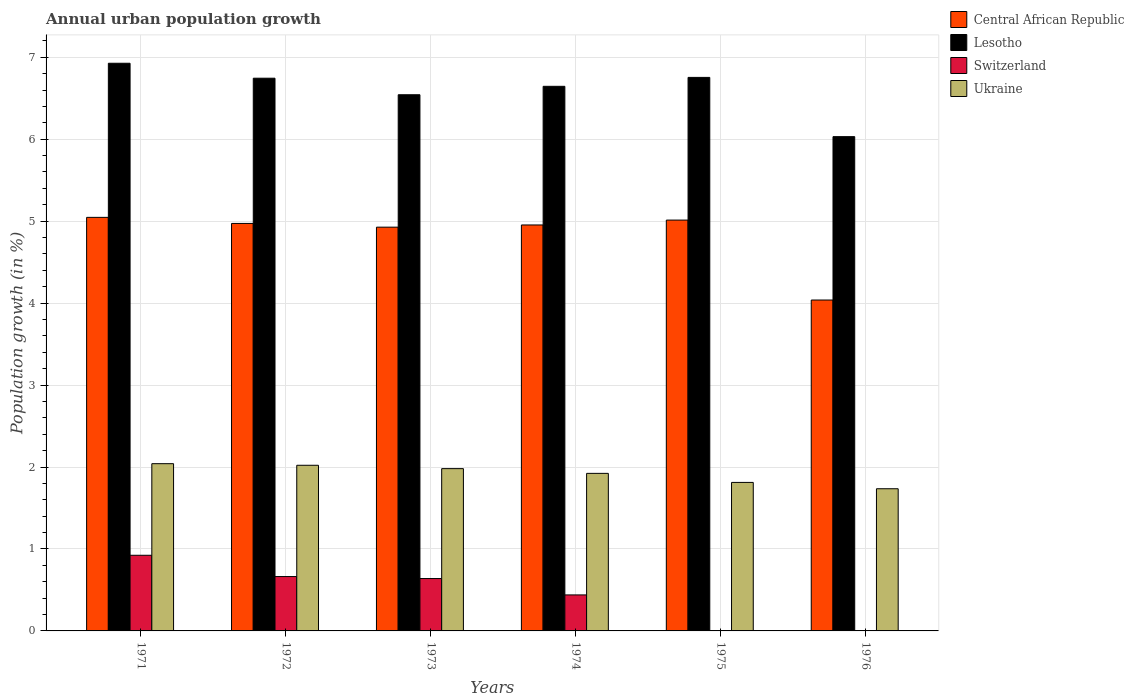How many different coloured bars are there?
Give a very brief answer. 4. Are the number of bars on each tick of the X-axis equal?
Your answer should be very brief. No. How many bars are there on the 5th tick from the right?
Your answer should be compact. 4. What is the label of the 2nd group of bars from the left?
Provide a short and direct response. 1972. In how many cases, is the number of bars for a given year not equal to the number of legend labels?
Keep it short and to the point. 2. What is the percentage of urban population growth in Ukraine in 1972?
Your response must be concise. 2.02. Across all years, what is the maximum percentage of urban population growth in Ukraine?
Make the answer very short. 2.04. What is the total percentage of urban population growth in Central African Republic in the graph?
Provide a short and direct response. 28.95. What is the difference between the percentage of urban population growth in Lesotho in 1972 and that in 1973?
Make the answer very short. 0.2. What is the difference between the percentage of urban population growth in Ukraine in 1975 and the percentage of urban population growth in Central African Republic in 1976?
Keep it short and to the point. -2.23. What is the average percentage of urban population growth in Ukraine per year?
Your answer should be very brief. 1.92. In the year 1975, what is the difference between the percentage of urban population growth in Central African Republic and percentage of urban population growth in Lesotho?
Your answer should be very brief. -1.74. What is the ratio of the percentage of urban population growth in Ukraine in 1973 to that in 1975?
Offer a terse response. 1.09. What is the difference between the highest and the second highest percentage of urban population growth in Central African Republic?
Make the answer very short. 0.03. What is the difference between the highest and the lowest percentage of urban population growth in Central African Republic?
Give a very brief answer. 1.01. Is the sum of the percentage of urban population growth in Lesotho in 1972 and 1975 greater than the maximum percentage of urban population growth in Switzerland across all years?
Ensure brevity in your answer.  Yes. What is the difference between two consecutive major ticks on the Y-axis?
Provide a short and direct response. 1. Are the values on the major ticks of Y-axis written in scientific E-notation?
Ensure brevity in your answer.  No. Does the graph contain grids?
Your response must be concise. Yes. Where does the legend appear in the graph?
Your response must be concise. Top right. What is the title of the graph?
Your answer should be very brief. Annual urban population growth. Does "South Africa" appear as one of the legend labels in the graph?
Offer a very short reply. No. What is the label or title of the Y-axis?
Your answer should be very brief. Population growth (in %). What is the Population growth (in %) of Central African Republic in 1971?
Your answer should be very brief. 5.05. What is the Population growth (in %) in Lesotho in 1971?
Give a very brief answer. 6.93. What is the Population growth (in %) in Switzerland in 1971?
Ensure brevity in your answer.  0.92. What is the Population growth (in %) in Ukraine in 1971?
Offer a very short reply. 2.04. What is the Population growth (in %) in Central African Republic in 1972?
Keep it short and to the point. 4.97. What is the Population growth (in %) in Lesotho in 1972?
Your response must be concise. 6.74. What is the Population growth (in %) of Switzerland in 1972?
Ensure brevity in your answer.  0.66. What is the Population growth (in %) in Ukraine in 1972?
Your answer should be very brief. 2.02. What is the Population growth (in %) of Central African Republic in 1973?
Ensure brevity in your answer.  4.93. What is the Population growth (in %) of Lesotho in 1973?
Provide a succinct answer. 6.54. What is the Population growth (in %) in Switzerland in 1973?
Ensure brevity in your answer.  0.64. What is the Population growth (in %) of Ukraine in 1973?
Give a very brief answer. 1.98. What is the Population growth (in %) of Central African Republic in 1974?
Keep it short and to the point. 4.95. What is the Population growth (in %) of Lesotho in 1974?
Give a very brief answer. 6.65. What is the Population growth (in %) in Switzerland in 1974?
Keep it short and to the point. 0.44. What is the Population growth (in %) of Ukraine in 1974?
Offer a terse response. 1.92. What is the Population growth (in %) of Central African Republic in 1975?
Your answer should be compact. 5.01. What is the Population growth (in %) of Lesotho in 1975?
Give a very brief answer. 6.75. What is the Population growth (in %) in Ukraine in 1975?
Give a very brief answer. 1.81. What is the Population growth (in %) in Central African Republic in 1976?
Keep it short and to the point. 4.04. What is the Population growth (in %) in Lesotho in 1976?
Your answer should be very brief. 6.03. What is the Population growth (in %) of Ukraine in 1976?
Your answer should be very brief. 1.73. Across all years, what is the maximum Population growth (in %) in Central African Republic?
Make the answer very short. 5.05. Across all years, what is the maximum Population growth (in %) in Lesotho?
Give a very brief answer. 6.93. Across all years, what is the maximum Population growth (in %) of Switzerland?
Offer a very short reply. 0.92. Across all years, what is the maximum Population growth (in %) in Ukraine?
Offer a terse response. 2.04. Across all years, what is the minimum Population growth (in %) of Central African Republic?
Make the answer very short. 4.04. Across all years, what is the minimum Population growth (in %) in Lesotho?
Provide a succinct answer. 6.03. Across all years, what is the minimum Population growth (in %) of Ukraine?
Your answer should be very brief. 1.73. What is the total Population growth (in %) of Central African Republic in the graph?
Give a very brief answer. 28.95. What is the total Population growth (in %) in Lesotho in the graph?
Give a very brief answer. 39.64. What is the total Population growth (in %) of Switzerland in the graph?
Give a very brief answer. 2.67. What is the total Population growth (in %) of Ukraine in the graph?
Your answer should be compact. 11.51. What is the difference between the Population growth (in %) in Central African Republic in 1971 and that in 1972?
Provide a succinct answer. 0.07. What is the difference between the Population growth (in %) of Lesotho in 1971 and that in 1972?
Provide a succinct answer. 0.18. What is the difference between the Population growth (in %) of Switzerland in 1971 and that in 1972?
Offer a terse response. 0.26. What is the difference between the Population growth (in %) of Ukraine in 1971 and that in 1972?
Your answer should be very brief. 0.02. What is the difference between the Population growth (in %) in Central African Republic in 1971 and that in 1973?
Your response must be concise. 0.12. What is the difference between the Population growth (in %) of Lesotho in 1971 and that in 1973?
Your answer should be very brief. 0.38. What is the difference between the Population growth (in %) in Switzerland in 1971 and that in 1973?
Give a very brief answer. 0.28. What is the difference between the Population growth (in %) in Ukraine in 1971 and that in 1973?
Make the answer very short. 0.06. What is the difference between the Population growth (in %) of Central African Republic in 1971 and that in 1974?
Your response must be concise. 0.09. What is the difference between the Population growth (in %) in Lesotho in 1971 and that in 1974?
Your response must be concise. 0.28. What is the difference between the Population growth (in %) in Switzerland in 1971 and that in 1974?
Ensure brevity in your answer.  0.48. What is the difference between the Population growth (in %) in Ukraine in 1971 and that in 1974?
Offer a terse response. 0.12. What is the difference between the Population growth (in %) of Central African Republic in 1971 and that in 1975?
Your answer should be compact. 0.03. What is the difference between the Population growth (in %) of Lesotho in 1971 and that in 1975?
Your answer should be very brief. 0.17. What is the difference between the Population growth (in %) in Ukraine in 1971 and that in 1975?
Your answer should be very brief. 0.23. What is the difference between the Population growth (in %) of Central African Republic in 1971 and that in 1976?
Provide a short and direct response. 1.01. What is the difference between the Population growth (in %) in Lesotho in 1971 and that in 1976?
Offer a terse response. 0.9. What is the difference between the Population growth (in %) of Ukraine in 1971 and that in 1976?
Your answer should be compact. 0.31. What is the difference between the Population growth (in %) of Central African Republic in 1972 and that in 1973?
Offer a very short reply. 0.05. What is the difference between the Population growth (in %) in Lesotho in 1972 and that in 1973?
Your answer should be very brief. 0.2. What is the difference between the Population growth (in %) in Switzerland in 1972 and that in 1973?
Offer a very short reply. 0.02. What is the difference between the Population growth (in %) in Ukraine in 1972 and that in 1973?
Provide a succinct answer. 0.04. What is the difference between the Population growth (in %) in Central African Republic in 1972 and that in 1974?
Offer a terse response. 0.02. What is the difference between the Population growth (in %) in Lesotho in 1972 and that in 1974?
Offer a terse response. 0.1. What is the difference between the Population growth (in %) in Switzerland in 1972 and that in 1974?
Your answer should be very brief. 0.22. What is the difference between the Population growth (in %) of Ukraine in 1972 and that in 1974?
Give a very brief answer. 0.1. What is the difference between the Population growth (in %) of Central African Republic in 1972 and that in 1975?
Make the answer very short. -0.04. What is the difference between the Population growth (in %) in Lesotho in 1972 and that in 1975?
Your answer should be very brief. -0.01. What is the difference between the Population growth (in %) of Ukraine in 1972 and that in 1975?
Your response must be concise. 0.21. What is the difference between the Population growth (in %) in Central African Republic in 1972 and that in 1976?
Provide a short and direct response. 0.93. What is the difference between the Population growth (in %) of Lesotho in 1972 and that in 1976?
Ensure brevity in your answer.  0.71. What is the difference between the Population growth (in %) of Ukraine in 1972 and that in 1976?
Your answer should be compact. 0.29. What is the difference between the Population growth (in %) in Central African Republic in 1973 and that in 1974?
Provide a short and direct response. -0.03. What is the difference between the Population growth (in %) in Lesotho in 1973 and that in 1974?
Make the answer very short. -0.1. What is the difference between the Population growth (in %) of Switzerland in 1973 and that in 1974?
Ensure brevity in your answer.  0.2. What is the difference between the Population growth (in %) of Ukraine in 1973 and that in 1974?
Offer a terse response. 0.06. What is the difference between the Population growth (in %) in Central African Republic in 1973 and that in 1975?
Give a very brief answer. -0.09. What is the difference between the Population growth (in %) in Lesotho in 1973 and that in 1975?
Provide a short and direct response. -0.21. What is the difference between the Population growth (in %) of Ukraine in 1973 and that in 1975?
Keep it short and to the point. 0.17. What is the difference between the Population growth (in %) of Central African Republic in 1973 and that in 1976?
Make the answer very short. 0.89. What is the difference between the Population growth (in %) in Lesotho in 1973 and that in 1976?
Make the answer very short. 0.51. What is the difference between the Population growth (in %) of Ukraine in 1973 and that in 1976?
Keep it short and to the point. 0.25. What is the difference between the Population growth (in %) in Central African Republic in 1974 and that in 1975?
Offer a very short reply. -0.06. What is the difference between the Population growth (in %) in Lesotho in 1974 and that in 1975?
Provide a succinct answer. -0.11. What is the difference between the Population growth (in %) of Ukraine in 1974 and that in 1975?
Offer a terse response. 0.11. What is the difference between the Population growth (in %) of Central African Republic in 1974 and that in 1976?
Keep it short and to the point. 0.92. What is the difference between the Population growth (in %) in Lesotho in 1974 and that in 1976?
Your response must be concise. 0.61. What is the difference between the Population growth (in %) of Ukraine in 1974 and that in 1976?
Ensure brevity in your answer.  0.19. What is the difference between the Population growth (in %) in Central African Republic in 1975 and that in 1976?
Provide a succinct answer. 0.98. What is the difference between the Population growth (in %) of Lesotho in 1975 and that in 1976?
Give a very brief answer. 0.72. What is the difference between the Population growth (in %) in Ukraine in 1975 and that in 1976?
Provide a succinct answer. 0.08. What is the difference between the Population growth (in %) in Central African Republic in 1971 and the Population growth (in %) in Lesotho in 1972?
Your response must be concise. -1.7. What is the difference between the Population growth (in %) of Central African Republic in 1971 and the Population growth (in %) of Switzerland in 1972?
Ensure brevity in your answer.  4.38. What is the difference between the Population growth (in %) in Central African Republic in 1971 and the Population growth (in %) in Ukraine in 1972?
Ensure brevity in your answer.  3.02. What is the difference between the Population growth (in %) of Lesotho in 1971 and the Population growth (in %) of Switzerland in 1972?
Offer a terse response. 6.26. What is the difference between the Population growth (in %) of Lesotho in 1971 and the Population growth (in %) of Ukraine in 1972?
Keep it short and to the point. 4.91. What is the difference between the Population growth (in %) of Switzerland in 1971 and the Population growth (in %) of Ukraine in 1972?
Provide a succinct answer. -1.1. What is the difference between the Population growth (in %) in Central African Republic in 1971 and the Population growth (in %) in Lesotho in 1973?
Keep it short and to the point. -1.5. What is the difference between the Population growth (in %) of Central African Republic in 1971 and the Population growth (in %) of Switzerland in 1973?
Ensure brevity in your answer.  4.41. What is the difference between the Population growth (in %) in Central African Republic in 1971 and the Population growth (in %) in Ukraine in 1973?
Keep it short and to the point. 3.07. What is the difference between the Population growth (in %) in Lesotho in 1971 and the Population growth (in %) in Switzerland in 1973?
Offer a terse response. 6.29. What is the difference between the Population growth (in %) in Lesotho in 1971 and the Population growth (in %) in Ukraine in 1973?
Your response must be concise. 4.95. What is the difference between the Population growth (in %) of Switzerland in 1971 and the Population growth (in %) of Ukraine in 1973?
Give a very brief answer. -1.06. What is the difference between the Population growth (in %) of Central African Republic in 1971 and the Population growth (in %) of Lesotho in 1974?
Provide a succinct answer. -1.6. What is the difference between the Population growth (in %) in Central African Republic in 1971 and the Population growth (in %) in Switzerland in 1974?
Provide a short and direct response. 4.61. What is the difference between the Population growth (in %) of Central African Republic in 1971 and the Population growth (in %) of Ukraine in 1974?
Make the answer very short. 3.12. What is the difference between the Population growth (in %) in Lesotho in 1971 and the Population growth (in %) in Switzerland in 1974?
Keep it short and to the point. 6.49. What is the difference between the Population growth (in %) of Lesotho in 1971 and the Population growth (in %) of Ukraine in 1974?
Your answer should be very brief. 5. What is the difference between the Population growth (in %) in Switzerland in 1971 and the Population growth (in %) in Ukraine in 1974?
Your response must be concise. -1. What is the difference between the Population growth (in %) in Central African Republic in 1971 and the Population growth (in %) in Lesotho in 1975?
Your answer should be compact. -1.71. What is the difference between the Population growth (in %) in Central African Republic in 1971 and the Population growth (in %) in Ukraine in 1975?
Provide a short and direct response. 3.23. What is the difference between the Population growth (in %) of Lesotho in 1971 and the Population growth (in %) of Ukraine in 1975?
Ensure brevity in your answer.  5.11. What is the difference between the Population growth (in %) of Switzerland in 1971 and the Population growth (in %) of Ukraine in 1975?
Make the answer very short. -0.89. What is the difference between the Population growth (in %) of Central African Republic in 1971 and the Population growth (in %) of Lesotho in 1976?
Provide a short and direct response. -0.98. What is the difference between the Population growth (in %) in Central African Republic in 1971 and the Population growth (in %) in Ukraine in 1976?
Give a very brief answer. 3.31. What is the difference between the Population growth (in %) of Lesotho in 1971 and the Population growth (in %) of Ukraine in 1976?
Ensure brevity in your answer.  5.19. What is the difference between the Population growth (in %) of Switzerland in 1971 and the Population growth (in %) of Ukraine in 1976?
Offer a very short reply. -0.81. What is the difference between the Population growth (in %) of Central African Republic in 1972 and the Population growth (in %) of Lesotho in 1973?
Provide a succinct answer. -1.57. What is the difference between the Population growth (in %) in Central African Republic in 1972 and the Population growth (in %) in Switzerland in 1973?
Your answer should be compact. 4.33. What is the difference between the Population growth (in %) in Central African Republic in 1972 and the Population growth (in %) in Ukraine in 1973?
Your response must be concise. 2.99. What is the difference between the Population growth (in %) in Lesotho in 1972 and the Population growth (in %) in Switzerland in 1973?
Make the answer very short. 6.11. What is the difference between the Population growth (in %) of Lesotho in 1972 and the Population growth (in %) of Ukraine in 1973?
Ensure brevity in your answer.  4.76. What is the difference between the Population growth (in %) of Switzerland in 1972 and the Population growth (in %) of Ukraine in 1973?
Offer a terse response. -1.32. What is the difference between the Population growth (in %) of Central African Republic in 1972 and the Population growth (in %) of Lesotho in 1974?
Your answer should be compact. -1.67. What is the difference between the Population growth (in %) of Central African Republic in 1972 and the Population growth (in %) of Switzerland in 1974?
Offer a terse response. 4.53. What is the difference between the Population growth (in %) of Central African Republic in 1972 and the Population growth (in %) of Ukraine in 1974?
Your answer should be very brief. 3.05. What is the difference between the Population growth (in %) in Lesotho in 1972 and the Population growth (in %) in Switzerland in 1974?
Provide a succinct answer. 6.3. What is the difference between the Population growth (in %) in Lesotho in 1972 and the Population growth (in %) in Ukraine in 1974?
Keep it short and to the point. 4.82. What is the difference between the Population growth (in %) in Switzerland in 1972 and the Population growth (in %) in Ukraine in 1974?
Ensure brevity in your answer.  -1.26. What is the difference between the Population growth (in %) of Central African Republic in 1972 and the Population growth (in %) of Lesotho in 1975?
Offer a very short reply. -1.78. What is the difference between the Population growth (in %) of Central African Republic in 1972 and the Population growth (in %) of Ukraine in 1975?
Make the answer very short. 3.16. What is the difference between the Population growth (in %) in Lesotho in 1972 and the Population growth (in %) in Ukraine in 1975?
Offer a very short reply. 4.93. What is the difference between the Population growth (in %) of Switzerland in 1972 and the Population growth (in %) of Ukraine in 1975?
Ensure brevity in your answer.  -1.15. What is the difference between the Population growth (in %) of Central African Republic in 1972 and the Population growth (in %) of Lesotho in 1976?
Make the answer very short. -1.06. What is the difference between the Population growth (in %) in Central African Republic in 1972 and the Population growth (in %) in Ukraine in 1976?
Offer a very short reply. 3.24. What is the difference between the Population growth (in %) in Lesotho in 1972 and the Population growth (in %) in Ukraine in 1976?
Offer a very short reply. 5.01. What is the difference between the Population growth (in %) in Switzerland in 1972 and the Population growth (in %) in Ukraine in 1976?
Provide a succinct answer. -1.07. What is the difference between the Population growth (in %) of Central African Republic in 1973 and the Population growth (in %) of Lesotho in 1974?
Your response must be concise. -1.72. What is the difference between the Population growth (in %) of Central African Republic in 1973 and the Population growth (in %) of Switzerland in 1974?
Provide a short and direct response. 4.49. What is the difference between the Population growth (in %) in Central African Republic in 1973 and the Population growth (in %) in Ukraine in 1974?
Offer a very short reply. 3. What is the difference between the Population growth (in %) in Lesotho in 1973 and the Population growth (in %) in Switzerland in 1974?
Ensure brevity in your answer.  6.1. What is the difference between the Population growth (in %) in Lesotho in 1973 and the Population growth (in %) in Ukraine in 1974?
Ensure brevity in your answer.  4.62. What is the difference between the Population growth (in %) of Switzerland in 1973 and the Population growth (in %) of Ukraine in 1974?
Give a very brief answer. -1.28. What is the difference between the Population growth (in %) of Central African Republic in 1973 and the Population growth (in %) of Lesotho in 1975?
Your answer should be very brief. -1.83. What is the difference between the Population growth (in %) of Central African Republic in 1973 and the Population growth (in %) of Ukraine in 1975?
Your answer should be compact. 3.11. What is the difference between the Population growth (in %) of Lesotho in 1973 and the Population growth (in %) of Ukraine in 1975?
Keep it short and to the point. 4.73. What is the difference between the Population growth (in %) of Switzerland in 1973 and the Population growth (in %) of Ukraine in 1975?
Provide a succinct answer. -1.17. What is the difference between the Population growth (in %) in Central African Republic in 1973 and the Population growth (in %) in Lesotho in 1976?
Provide a short and direct response. -1.1. What is the difference between the Population growth (in %) in Central African Republic in 1973 and the Population growth (in %) in Ukraine in 1976?
Keep it short and to the point. 3.19. What is the difference between the Population growth (in %) in Lesotho in 1973 and the Population growth (in %) in Ukraine in 1976?
Provide a succinct answer. 4.81. What is the difference between the Population growth (in %) in Switzerland in 1973 and the Population growth (in %) in Ukraine in 1976?
Offer a very short reply. -1.1. What is the difference between the Population growth (in %) in Central African Republic in 1974 and the Population growth (in %) in Lesotho in 1975?
Offer a terse response. -1.8. What is the difference between the Population growth (in %) in Central African Republic in 1974 and the Population growth (in %) in Ukraine in 1975?
Give a very brief answer. 3.14. What is the difference between the Population growth (in %) of Lesotho in 1974 and the Population growth (in %) of Ukraine in 1975?
Give a very brief answer. 4.83. What is the difference between the Population growth (in %) in Switzerland in 1974 and the Population growth (in %) in Ukraine in 1975?
Ensure brevity in your answer.  -1.37. What is the difference between the Population growth (in %) of Central African Republic in 1974 and the Population growth (in %) of Lesotho in 1976?
Provide a short and direct response. -1.08. What is the difference between the Population growth (in %) in Central African Republic in 1974 and the Population growth (in %) in Ukraine in 1976?
Your answer should be very brief. 3.22. What is the difference between the Population growth (in %) in Lesotho in 1974 and the Population growth (in %) in Ukraine in 1976?
Provide a succinct answer. 4.91. What is the difference between the Population growth (in %) in Switzerland in 1974 and the Population growth (in %) in Ukraine in 1976?
Make the answer very short. -1.3. What is the difference between the Population growth (in %) in Central African Republic in 1975 and the Population growth (in %) in Lesotho in 1976?
Provide a short and direct response. -1.02. What is the difference between the Population growth (in %) in Central African Republic in 1975 and the Population growth (in %) in Ukraine in 1976?
Provide a succinct answer. 3.28. What is the difference between the Population growth (in %) in Lesotho in 1975 and the Population growth (in %) in Ukraine in 1976?
Your answer should be very brief. 5.02. What is the average Population growth (in %) of Central African Republic per year?
Provide a succinct answer. 4.83. What is the average Population growth (in %) of Lesotho per year?
Provide a succinct answer. 6.61. What is the average Population growth (in %) in Switzerland per year?
Provide a succinct answer. 0.44. What is the average Population growth (in %) of Ukraine per year?
Provide a short and direct response. 1.92. In the year 1971, what is the difference between the Population growth (in %) in Central African Republic and Population growth (in %) in Lesotho?
Offer a terse response. -1.88. In the year 1971, what is the difference between the Population growth (in %) of Central African Republic and Population growth (in %) of Switzerland?
Ensure brevity in your answer.  4.12. In the year 1971, what is the difference between the Population growth (in %) in Central African Republic and Population growth (in %) in Ukraine?
Provide a short and direct response. 3.01. In the year 1971, what is the difference between the Population growth (in %) of Lesotho and Population growth (in %) of Switzerland?
Your response must be concise. 6. In the year 1971, what is the difference between the Population growth (in %) of Lesotho and Population growth (in %) of Ukraine?
Offer a terse response. 4.89. In the year 1971, what is the difference between the Population growth (in %) in Switzerland and Population growth (in %) in Ukraine?
Provide a short and direct response. -1.12. In the year 1972, what is the difference between the Population growth (in %) of Central African Republic and Population growth (in %) of Lesotho?
Provide a short and direct response. -1.77. In the year 1972, what is the difference between the Population growth (in %) in Central African Republic and Population growth (in %) in Switzerland?
Your answer should be very brief. 4.31. In the year 1972, what is the difference between the Population growth (in %) of Central African Republic and Population growth (in %) of Ukraine?
Make the answer very short. 2.95. In the year 1972, what is the difference between the Population growth (in %) of Lesotho and Population growth (in %) of Switzerland?
Ensure brevity in your answer.  6.08. In the year 1972, what is the difference between the Population growth (in %) in Lesotho and Population growth (in %) in Ukraine?
Keep it short and to the point. 4.72. In the year 1972, what is the difference between the Population growth (in %) in Switzerland and Population growth (in %) in Ukraine?
Provide a succinct answer. -1.36. In the year 1973, what is the difference between the Population growth (in %) of Central African Republic and Population growth (in %) of Lesotho?
Ensure brevity in your answer.  -1.62. In the year 1973, what is the difference between the Population growth (in %) in Central African Republic and Population growth (in %) in Switzerland?
Ensure brevity in your answer.  4.29. In the year 1973, what is the difference between the Population growth (in %) in Central African Republic and Population growth (in %) in Ukraine?
Ensure brevity in your answer.  2.95. In the year 1973, what is the difference between the Population growth (in %) in Lesotho and Population growth (in %) in Switzerland?
Offer a terse response. 5.9. In the year 1973, what is the difference between the Population growth (in %) of Lesotho and Population growth (in %) of Ukraine?
Your response must be concise. 4.56. In the year 1973, what is the difference between the Population growth (in %) in Switzerland and Population growth (in %) in Ukraine?
Offer a very short reply. -1.34. In the year 1974, what is the difference between the Population growth (in %) in Central African Republic and Population growth (in %) in Lesotho?
Your answer should be compact. -1.69. In the year 1974, what is the difference between the Population growth (in %) of Central African Republic and Population growth (in %) of Switzerland?
Ensure brevity in your answer.  4.51. In the year 1974, what is the difference between the Population growth (in %) of Central African Republic and Population growth (in %) of Ukraine?
Give a very brief answer. 3.03. In the year 1974, what is the difference between the Population growth (in %) of Lesotho and Population growth (in %) of Switzerland?
Your answer should be compact. 6.21. In the year 1974, what is the difference between the Population growth (in %) in Lesotho and Population growth (in %) in Ukraine?
Give a very brief answer. 4.72. In the year 1974, what is the difference between the Population growth (in %) of Switzerland and Population growth (in %) of Ukraine?
Provide a short and direct response. -1.48. In the year 1975, what is the difference between the Population growth (in %) of Central African Republic and Population growth (in %) of Lesotho?
Your answer should be compact. -1.74. In the year 1975, what is the difference between the Population growth (in %) of Central African Republic and Population growth (in %) of Ukraine?
Your answer should be compact. 3.2. In the year 1975, what is the difference between the Population growth (in %) in Lesotho and Population growth (in %) in Ukraine?
Provide a succinct answer. 4.94. In the year 1976, what is the difference between the Population growth (in %) in Central African Republic and Population growth (in %) in Lesotho?
Ensure brevity in your answer.  -1.99. In the year 1976, what is the difference between the Population growth (in %) in Central African Republic and Population growth (in %) in Ukraine?
Your answer should be compact. 2.3. In the year 1976, what is the difference between the Population growth (in %) of Lesotho and Population growth (in %) of Ukraine?
Make the answer very short. 4.3. What is the ratio of the Population growth (in %) in Central African Republic in 1971 to that in 1972?
Offer a very short reply. 1.01. What is the ratio of the Population growth (in %) in Lesotho in 1971 to that in 1972?
Make the answer very short. 1.03. What is the ratio of the Population growth (in %) of Switzerland in 1971 to that in 1972?
Your response must be concise. 1.39. What is the ratio of the Population growth (in %) of Ukraine in 1971 to that in 1972?
Offer a very short reply. 1.01. What is the ratio of the Population growth (in %) of Central African Republic in 1971 to that in 1973?
Provide a short and direct response. 1.02. What is the ratio of the Population growth (in %) in Lesotho in 1971 to that in 1973?
Your answer should be compact. 1.06. What is the ratio of the Population growth (in %) of Switzerland in 1971 to that in 1973?
Your answer should be compact. 1.44. What is the ratio of the Population growth (in %) in Ukraine in 1971 to that in 1973?
Ensure brevity in your answer.  1.03. What is the ratio of the Population growth (in %) of Central African Republic in 1971 to that in 1974?
Provide a succinct answer. 1.02. What is the ratio of the Population growth (in %) of Lesotho in 1971 to that in 1974?
Offer a terse response. 1.04. What is the ratio of the Population growth (in %) of Switzerland in 1971 to that in 1974?
Offer a terse response. 2.1. What is the ratio of the Population growth (in %) in Ukraine in 1971 to that in 1974?
Ensure brevity in your answer.  1.06. What is the ratio of the Population growth (in %) of Central African Republic in 1971 to that in 1975?
Provide a short and direct response. 1.01. What is the ratio of the Population growth (in %) of Lesotho in 1971 to that in 1975?
Provide a short and direct response. 1.03. What is the ratio of the Population growth (in %) in Ukraine in 1971 to that in 1975?
Provide a short and direct response. 1.13. What is the ratio of the Population growth (in %) in Central African Republic in 1971 to that in 1976?
Your answer should be compact. 1.25. What is the ratio of the Population growth (in %) of Lesotho in 1971 to that in 1976?
Ensure brevity in your answer.  1.15. What is the ratio of the Population growth (in %) in Ukraine in 1971 to that in 1976?
Keep it short and to the point. 1.18. What is the ratio of the Population growth (in %) of Central African Republic in 1972 to that in 1973?
Provide a succinct answer. 1.01. What is the ratio of the Population growth (in %) of Lesotho in 1972 to that in 1973?
Your response must be concise. 1.03. What is the ratio of the Population growth (in %) of Switzerland in 1972 to that in 1973?
Your answer should be very brief. 1.04. What is the ratio of the Population growth (in %) in Ukraine in 1972 to that in 1973?
Your answer should be compact. 1.02. What is the ratio of the Population growth (in %) of Lesotho in 1972 to that in 1974?
Your response must be concise. 1.01. What is the ratio of the Population growth (in %) in Switzerland in 1972 to that in 1974?
Make the answer very short. 1.51. What is the ratio of the Population growth (in %) of Ukraine in 1972 to that in 1974?
Provide a succinct answer. 1.05. What is the ratio of the Population growth (in %) in Lesotho in 1972 to that in 1975?
Your response must be concise. 1. What is the ratio of the Population growth (in %) in Ukraine in 1972 to that in 1975?
Your answer should be very brief. 1.12. What is the ratio of the Population growth (in %) in Central African Republic in 1972 to that in 1976?
Offer a very short reply. 1.23. What is the ratio of the Population growth (in %) of Lesotho in 1972 to that in 1976?
Offer a very short reply. 1.12. What is the ratio of the Population growth (in %) of Ukraine in 1972 to that in 1976?
Give a very brief answer. 1.17. What is the ratio of the Population growth (in %) of Central African Republic in 1973 to that in 1974?
Ensure brevity in your answer.  0.99. What is the ratio of the Population growth (in %) of Lesotho in 1973 to that in 1974?
Give a very brief answer. 0.98. What is the ratio of the Population growth (in %) of Switzerland in 1973 to that in 1974?
Offer a terse response. 1.45. What is the ratio of the Population growth (in %) of Central African Republic in 1973 to that in 1975?
Your response must be concise. 0.98. What is the ratio of the Population growth (in %) of Lesotho in 1973 to that in 1975?
Make the answer very short. 0.97. What is the ratio of the Population growth (in %) in Ukraine in 1973 to that in 1975?
Ensure brevity in your answer.  1.09. What is the ratio of the Population growth (in %) of Central African Republic in 1973 to that in 1976?
Offer a terse response. 1.22. What is the ratio of the Population growth (in %) of Lesotho in 1973 to that in 1976?
Offer a very short reply. 1.08. What is the ratio of the Population growth (in %) in Ukraine in 1973 to that in 1976?
Offer a very short reply. 1.14. What is the ratio of the Population growth (in %) in Central African Republic in 1974 to that in 1975?
Your answer should be compact. 0.99. What is the ratio of the Population growth (in %) in Lesotho in 1974 to that in 1975?
Ensure brevity in your answer.  0.98. What is the ratio of the Population growth (in %) in Ukraine in 1974 to that in 1975?
Your answer should be very brief. 1.06. What is the ratio of the Population growth (in %) of Central African Republic in 1974 to that in 1976?
Provide a succinct answer. 1.23. What is the ratio of the Population growth (in %) in Lesotho in 1974 to that in 1976?
Your response must be concise. 1.1. What is the ratio of the Population growth (in %) in Ukraine in 1974 to that in 1976?
Ensure brevity in your answer.  1.11. What is the ratio of the Population growth (in %) in Central African Republic in 1975 to that in 1976?
Your answer should be very brief. 1.24. What is the ratio of the Population growth (in %) in Lesotho in 1975 to that in 1976?
Your answer should be very brief. 1.12. What is the ratio of the Population growth (in %) of Ukraine in 1975 to that in 1976?
Ensure brevity in your answer.  1.04. What is the difference between the highest and the second highest Population growth (in %) of Central African Republic?
Give a very brief answer. 0.03. What is the difference between the highest and the second highest Population growth (in %) in Lesotho?
Offer a very short reply. 0.17. What is the difference between the highest and the second highest Population growth (in %) of Switzerland?
Offer a terse response. 0.26. What is the difference between the highest and the second highest Population growth (in %) of Ukraine?
Provide a succinct answer. 0.02. What is the difference between the highest and the lowest Population growth (in %) of Central African Republic?
Ensure brevity in your answer.  1.01. What is the difference between the highest and the lowest Population growth (in %) in Lesotho?
Provide a succinct answer. 0.9. What is the difference between the highest and the lowest Population growth (in %) of Switzerland?
Provide a succinct answer. 0.92. What is the difference between the highest and the lowest Population growth (in %) in Ukraine?
Provide a short and direct response. 0.31. 